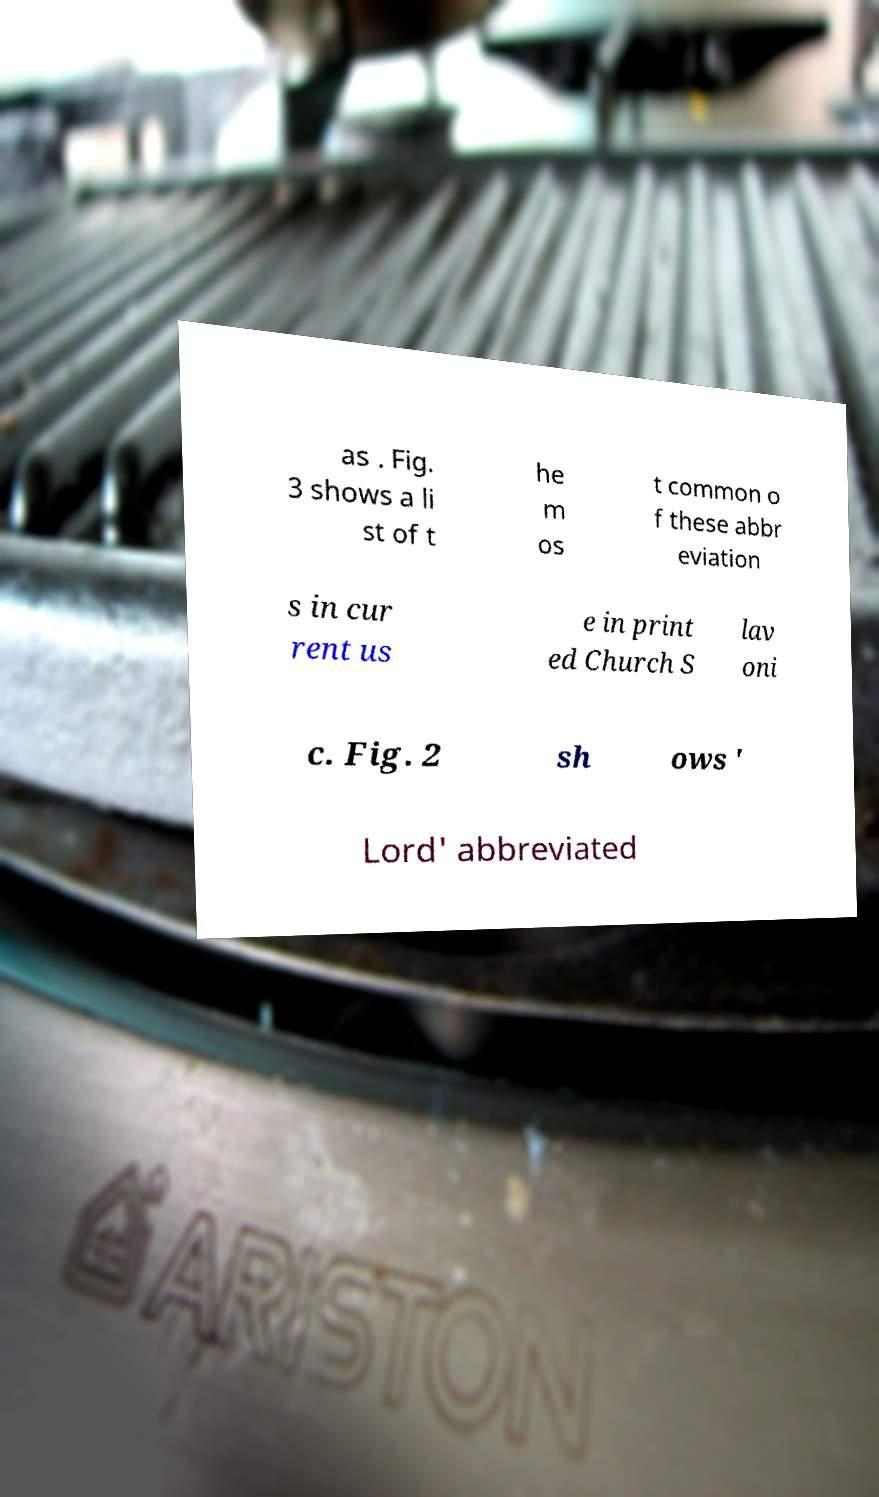Could you assist in decoding the text presented in this image and type it out clearly? as . Fig. 3 shows a li st of t he m os t common o f these abbr eviation s in cur rent us e in print ed Church S lav oni c. Fig. 2 sh ows ' Lord' abbreviated 